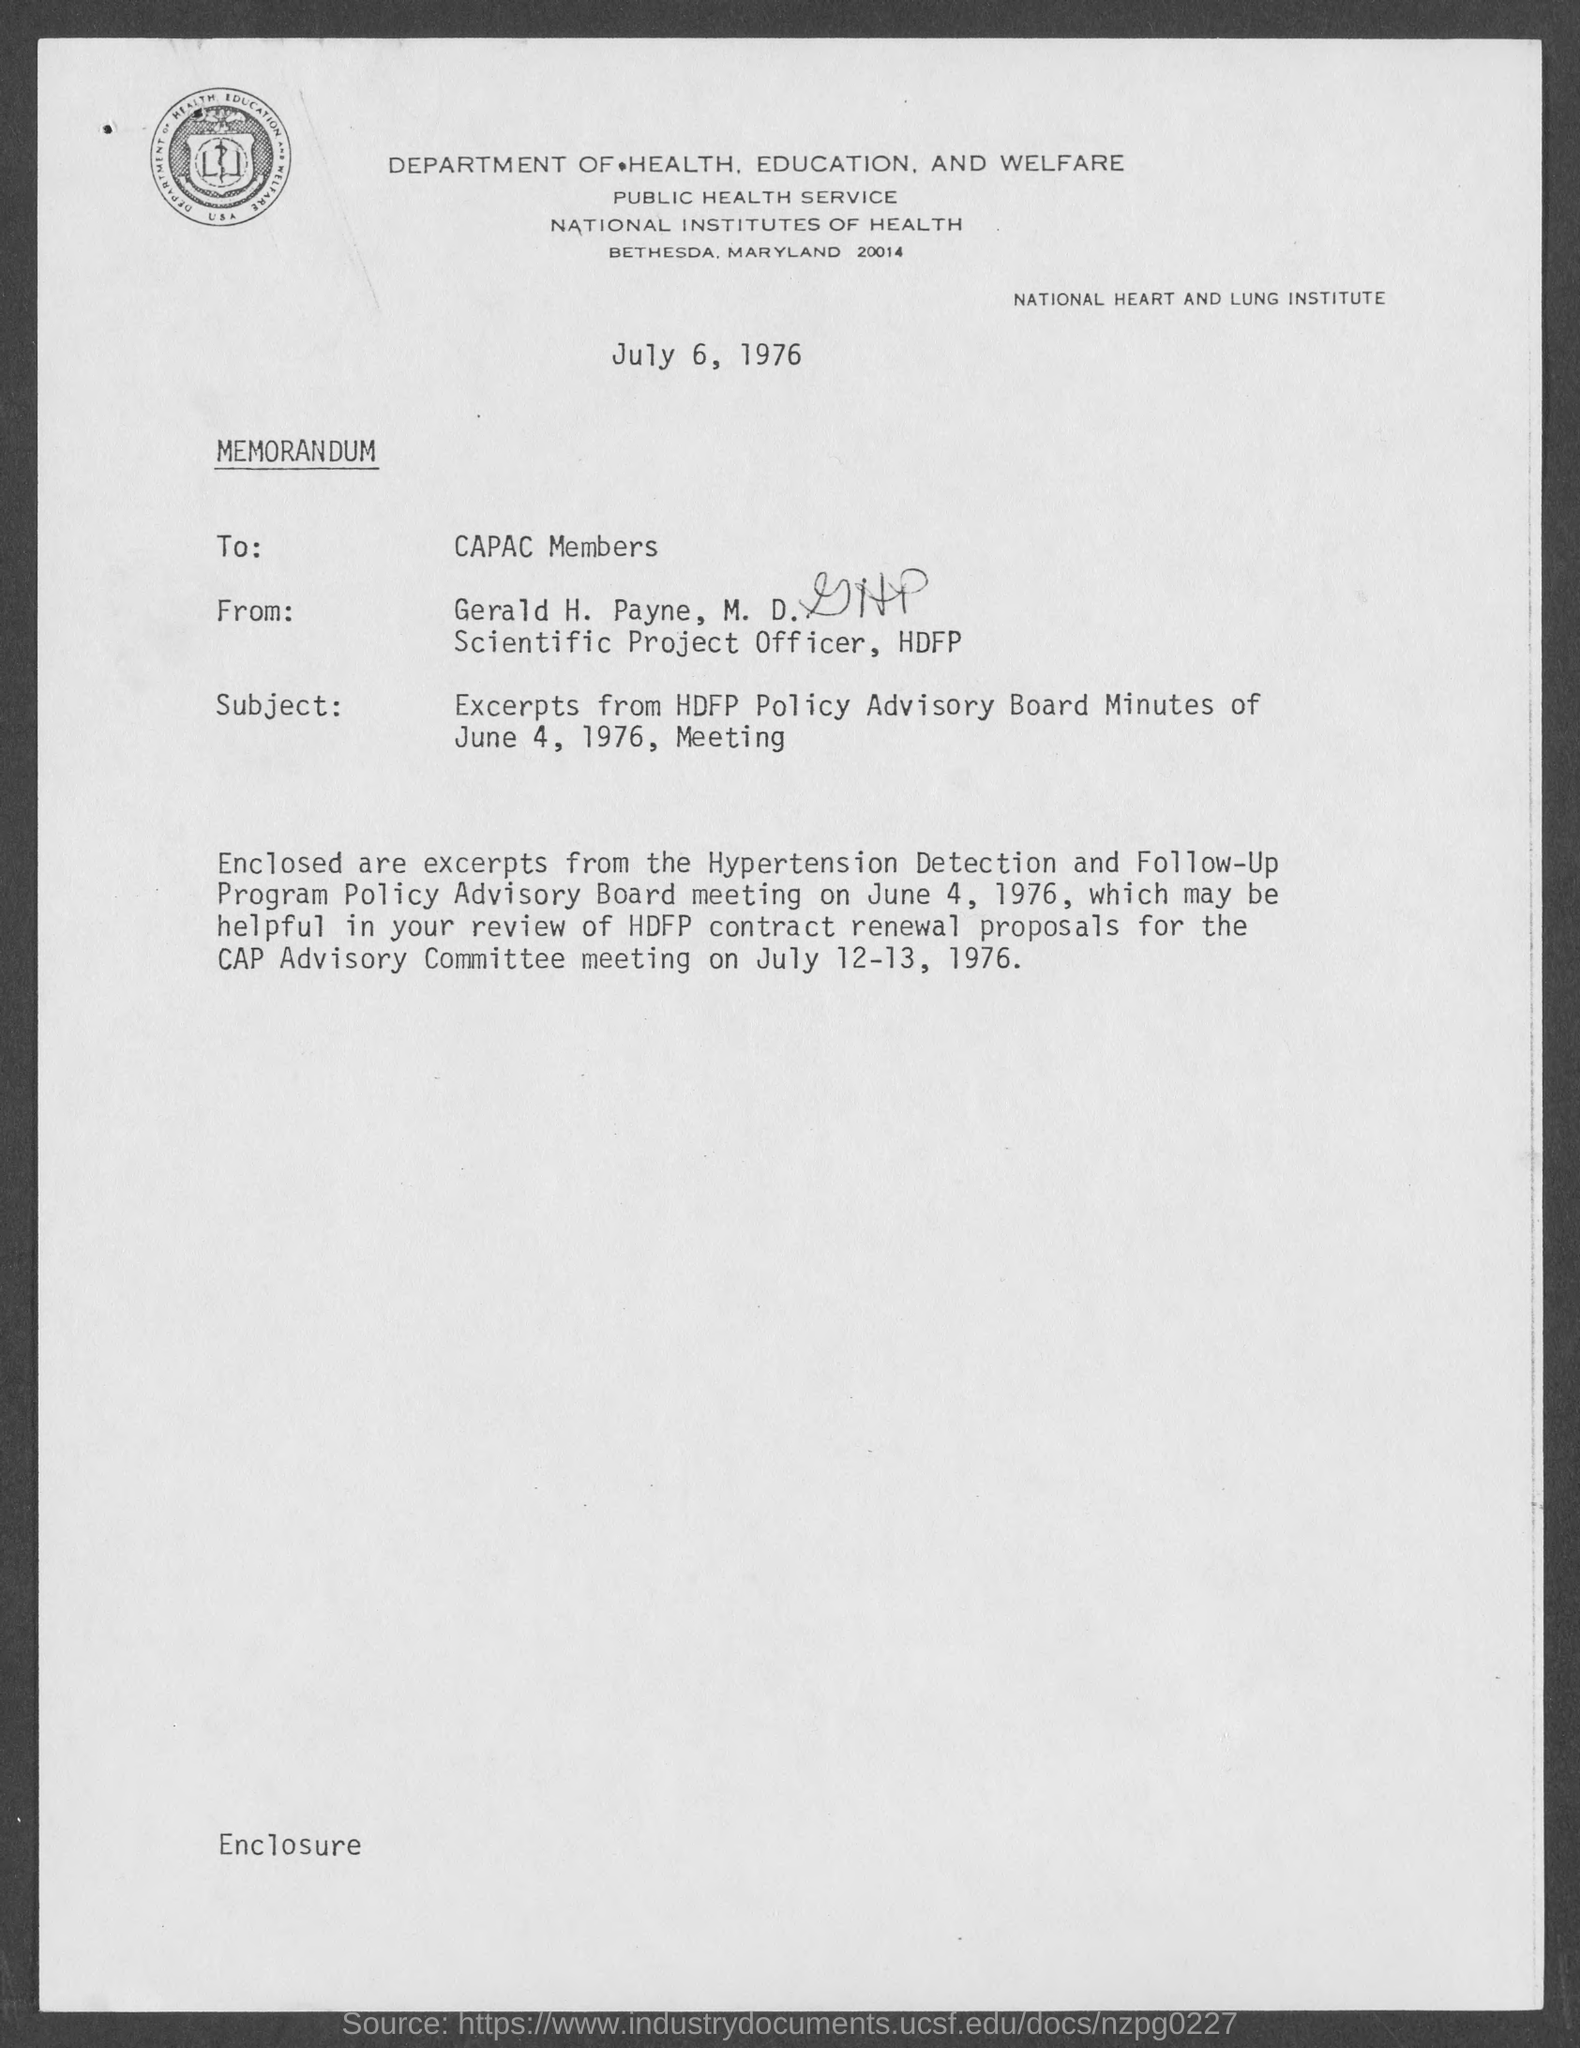List a handful of essential elements in this visual. The Hypertension Detection and Follow-Up Program Policy Advisory Board meeting is scheduled for June 4, 1976. The memorandum is dated July 6, 1976. Gerald H. Payne, M.D. holds the position of Scientific Project Officer. 